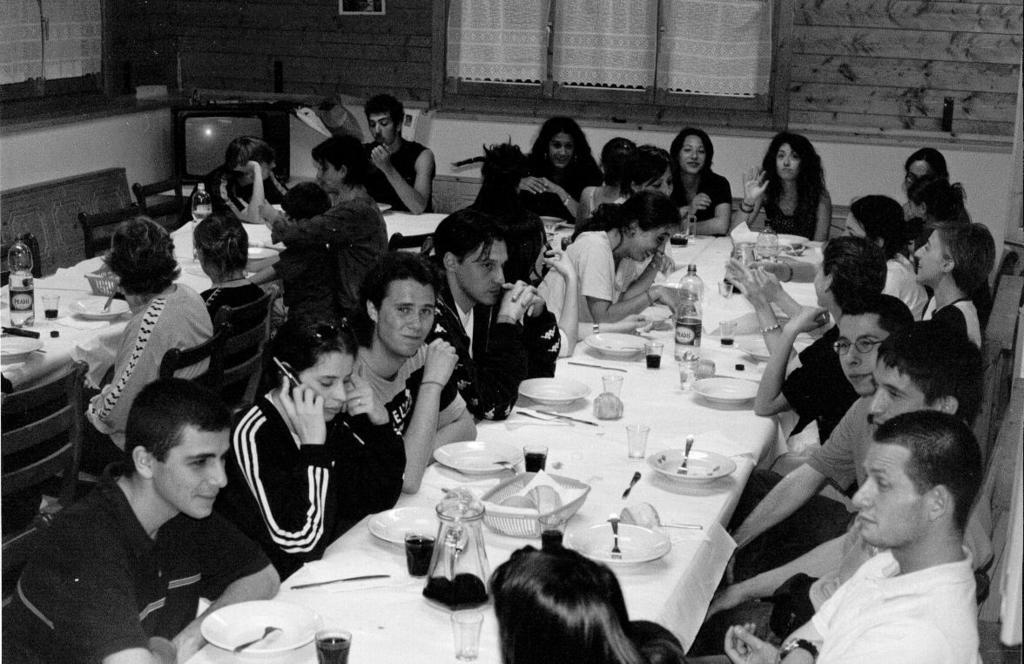In one or two sentences, can you explain what this image depicts? A black and white picture. Persons are sitting on chairs. In-front of them there are tables, on tables there are bottles, glasses and plates. On the corner of the image there is a television. 